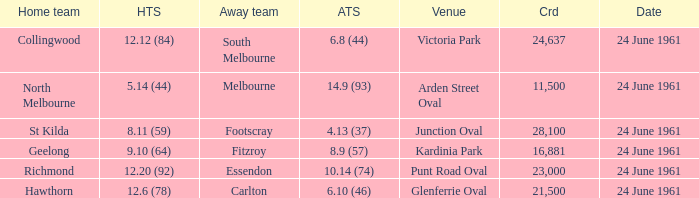6 (78)? Hawthorn. 